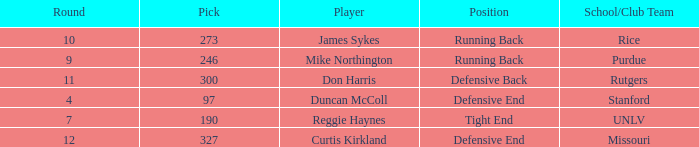What is the highest round number for the player who came from team Missouri? 12.0. 